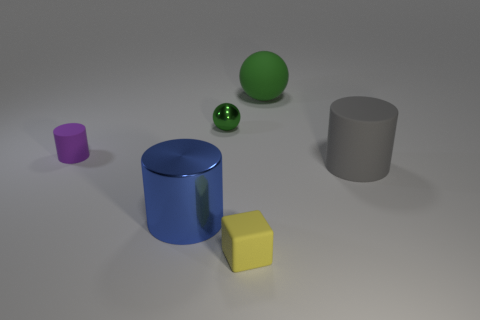Subtract all purple cylinders. How many cylinders are left? 2 Add 3 small purple matte things. How many objects exist? 9 Subtract all gray cylinders. How many cylinders are left? 2 Subtract all balls. How many objects are left? 4 Subtract 1 cylinders. How many cylinders are left? 2 Subtract all green balls. Subtract all brown metallic spheres. How many objects are left? 4 Add 5 large gray rubber cylinders. How many large gray rubber cylinders are left? 6 Add 5 gray things. How many gray things exist? 6 Subtract 0 purple cubes. How many objects are left? 6 Subtract all gray blocks. Subtract all green balls. How many blocks are left? 1 